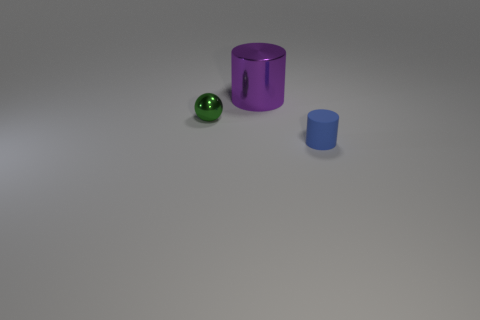Add 2 big purple cylinders. How many objects exist? 5 Subtract all cylinders. How many objects are left? 1 Add 1 balls. How many balls are left? 2 Add 3 large cylinders. How many large cylinders exist? 4 Subtract 0 brown cylinders. How many objects are left? 3 Subtract all balls. Subtract all big purple metallic cylinders. How many objects are left? 1 